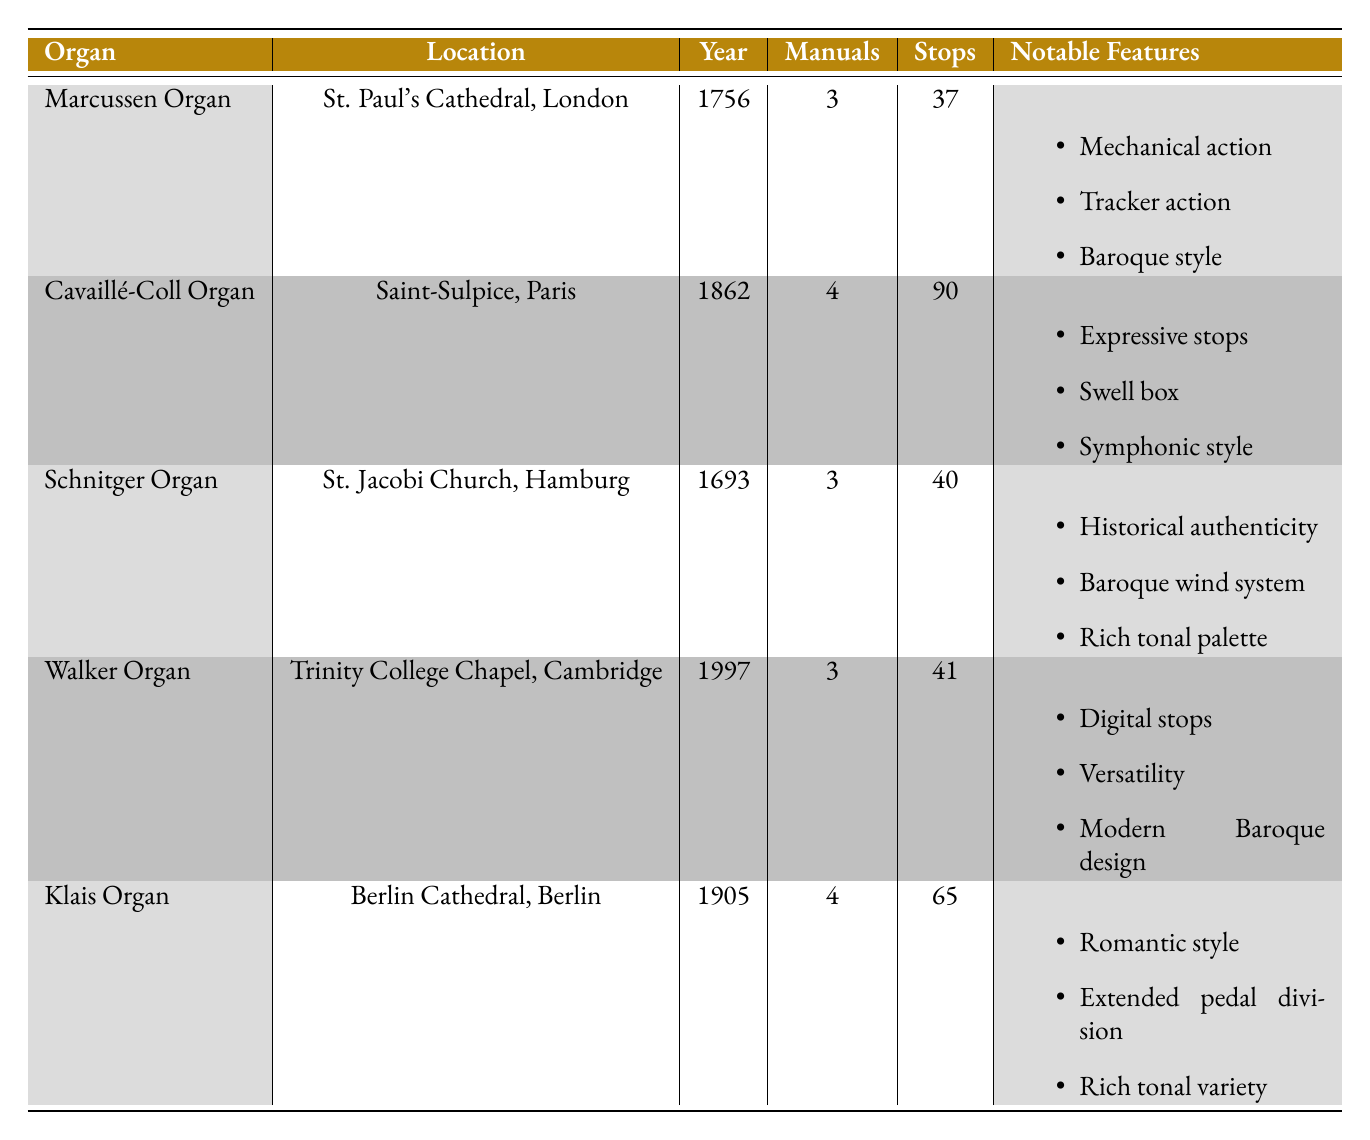What is the year of installation for the Schnitger Organ? The table lists the Schnitger Organ with the year installed as 1693.
Answer: 1693 Which organ has the highest number of stops? From the table, the organ with the highest number of stops is the Cavaillé-Coll Organ with 90 stops.
Answer: Cavaillé-Coll Organ How many manuals does the Marcussen Organ have? The table indicates that the Marcussen Organ has 3 manuals listed.
Answer: 3 Is the Walker Organ a Baroque style organ? The Walker Organ is noted for its "Modern Baroque design" but it also includes "Digital stops" and "Versatility," suggesting it does not strictly conform to traditional Baroque style.
Answer: No What is the difference in the number of stops between the Klais Organ and the Marcussen Organ? The Klais Organ has 65 stops and the Marcussen Organ has 37 stops; subtracting gives 65 - 37 = 28, indicating 28 more stops for the Klais Organ.
Answer: 28 Which organs were installed before the year 1800? The Schnitger Organ (1693), the Marcussen Organ (1756) are the only organs installed before 1800. A quick look at the year installed confirms this.
Answer: Schnitger Organ, Marcussen Organ What is the total number of manuals across all organs? Summing the manuals: 3 (Marcussen) + 4 (Cavaillé-Coll) + 3 (Schnitger) + 3 (Walker) + 4 (Klais) totals to 17 manuals.
Answer: 17 Is the Klais Organ noted for its expressive stops? The table indicates that the Klais Organ features "Romantic style" and "Rich tonal variety," but does not mention expressive stops. Hence, it does not have this feature.
Answer: No Which organ has a tracker action, and where is it located? The table shows that the Marcussen Organ has a tracker action feature, located in St. Paul's Cathedral, London.
Answer: Marcussen Organ, St. Paul's Cathedral, London 